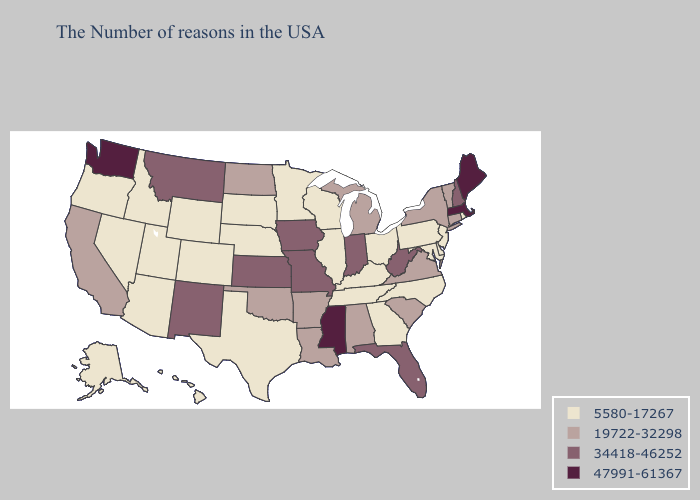Name the states that have a value in the range 47991-61367?
Short answer required. Maine, Massachusetts, Mississippi, Washington. Does Vermont have the lowest value in the Northeast?
Short answer required. No. Does Nevada have a lower value than Minnesota?
Quick response, please. No. What is the lowest value in the South?
Concise answer only. 5580-17267. Name the states that have a value in the range 34418-46252?
Concise answer only. New Hampshire, West Virginia, Florida, Indiana, Missouri, Iowa, Kansas, New Mexico, Montana. Does North Dakota have the lowest value in the USA?
Be succinct. No. Does the first symbol in the legend represent the smallest category?
Concise answer only. Yes. Does Utah have the same value as Rhode Island?
Answer briefly. Yes. What is the value of New York?
Write a very short answer. 19722-32298. Name the states that have a value in the range 34418-46252?
Answer briefly. New Hampshire, West Virginia, Florida, Indiana, Missouri, Iowa, Kansas, New Mexico, Montana. Name the states that have a value in the range 5580-17267?
Answer briefly. Rhode Island, New Jersey, Delaware, Maryland, Pennsylvania, North Carolina, Ohio, Georgia, Kentucky, Tennessee, Wisconsin, Illinois, Minnesota, Nebraska, Texas, South Dakota, Wyoming, Colorado, Utah, Arizona, Idaho, Nevada, Oregon, Alaska, Hawaii. What is the value of North Dakota?
Keep it brief. 19722-32298. Does Arkansas have a higher value than Missouri?
Give a very brief answer. No. Does the map have missing data?
Keep it brief. No. 